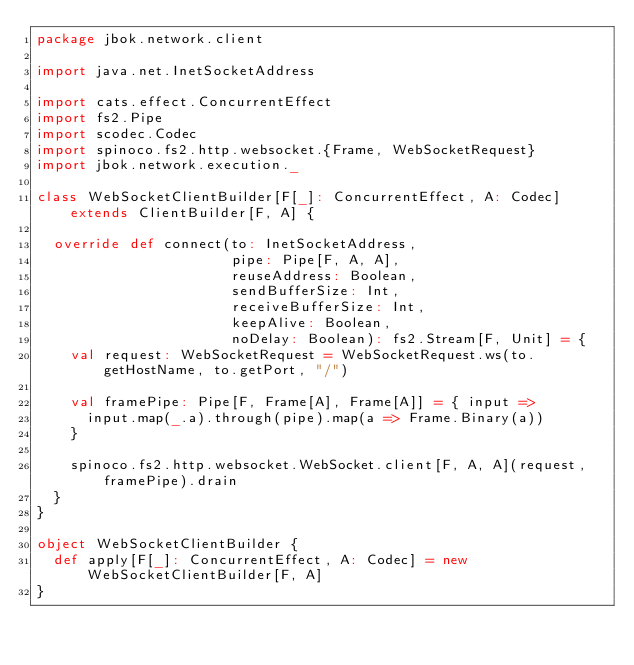Convert code to text. <code><loc_0><loc_0><loc_500><loc_500><_Scala_>package jbok.network.client

import java.net.InetSocketAddress

import cats.effect.ConcurrentEffect
import fs2.Pipe
import scodec.Codec
import spinoco.fs2.http.websocket.{Frame, WebSocketRequest}
import jbok.network.execution._

class WebSocketClientBuilder[F[_]: ConcurrentEffect, A: Codec] extends ClientBuilder[F, A] {

  override def connect(to: InetSocketAddress,
                       pipe: Pipe[F, A, A],
                       reuseAddress: Boolean,
                       sendBufferSize: Int,
                       receiveBufferSize: Int,
                       keepAlive: Boolean,
                       noDelay: Boolean): fs2.Stream[F, Unit] = {
    val request: WebSocketRequest = WebSocketRequest.ws(to.getHostName, to.getPort, "/")

    val framePipe: Pipe[F, Frame[A], Frame[A]] = { input =>
      input.map(_.a).through(pipe).map(a => Frame.Binary(a))
    }

    spinoco.fs2.http.websocket.WebSocket.client[F, A, A](request, framePipe).drain
  }
}

object WebSocketClientBuilder {
  def apply[F[_]: ConcurrentEffect, A: Codec] = new WebSocketClientBuilder[F, A]
}
</code> 